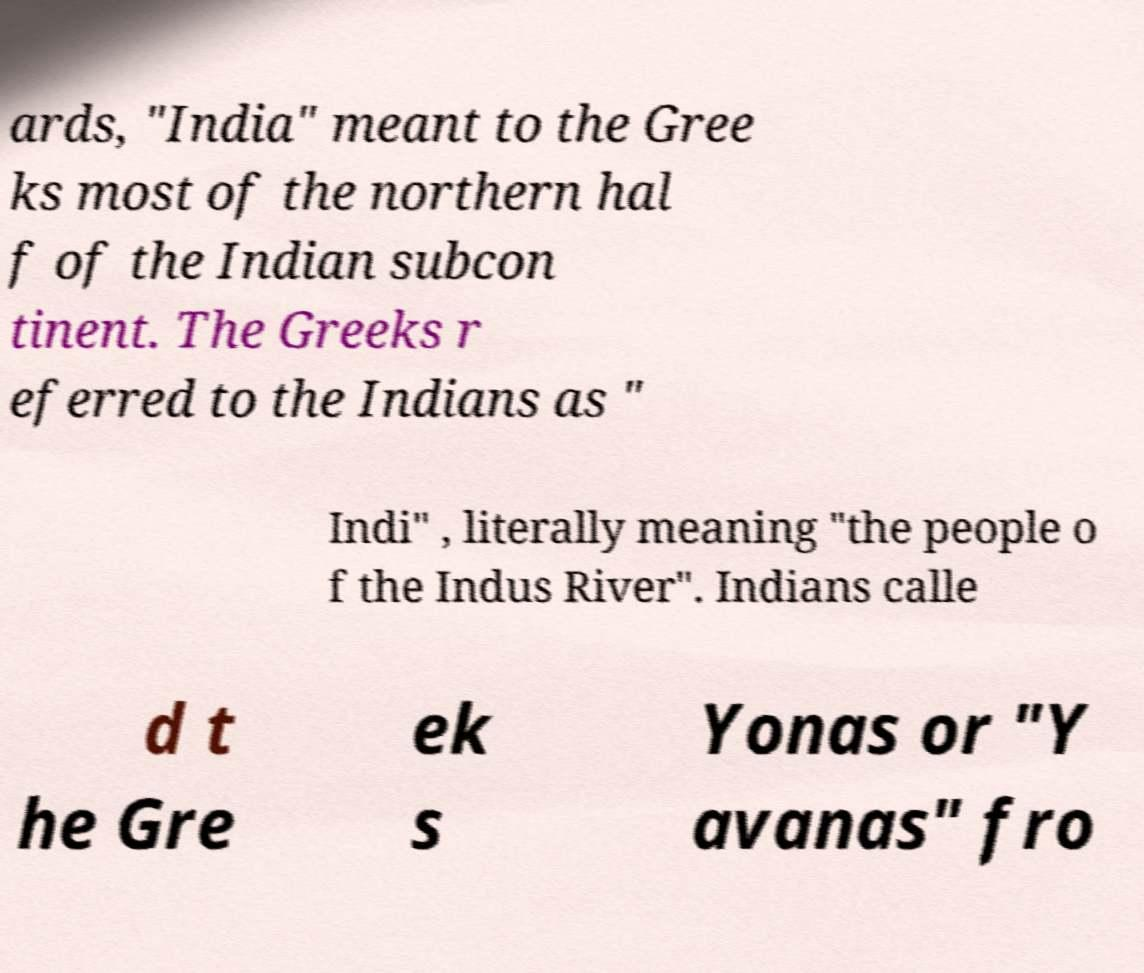What messages or text are displayed in this image? I need them in a readable, typed format. ards, "India" meant to the Gree ks most of the northern hal f of the Indian subcon tinent. The Greeks r eferred to the Indians as " Indi" , literally meaning "the people o f the Indus River". Indians calle d t he Gre ek s Yonas or "Y avanas" fro 